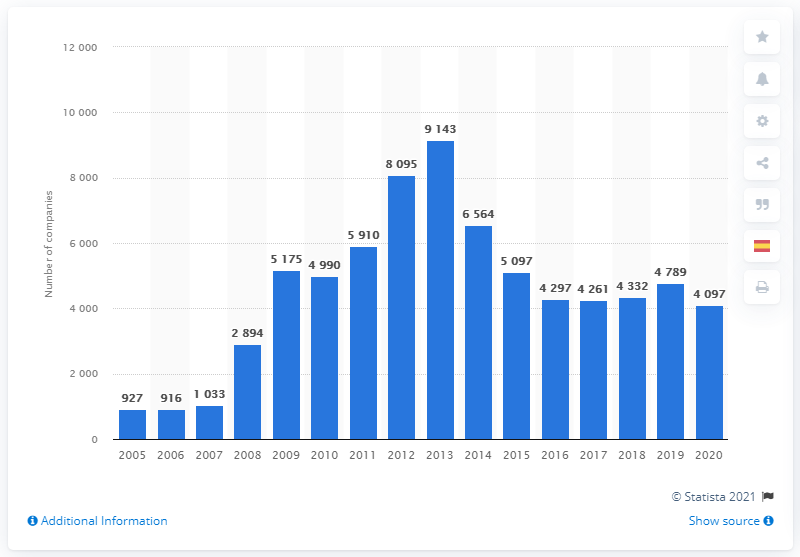What trends can be observed in the number of bankruptcies from 2005 to 2020? The bar graph shows a fluctuating trend in bankruptcies from 2005 to 2020. Initially, the number increases, reaching a peak in 2009, after which it generally trends downward, with a few small upticks. The overall movement is from a higher number of bankruptcies during the late-2000s recession to fewer in the following years.  Could you identify any specific years where there is a significant change or pattern? Certainly! Major changes can be seen in the transition years of 2009-2010, where there is a sharp decrease in bankruptcies. Another noticeable shift happens between 2014 and 2015, marking a slight increase followed by a decrease. The overall trend appears cyclical with some years showing increases that are eventually balanced by subsequent declines. 